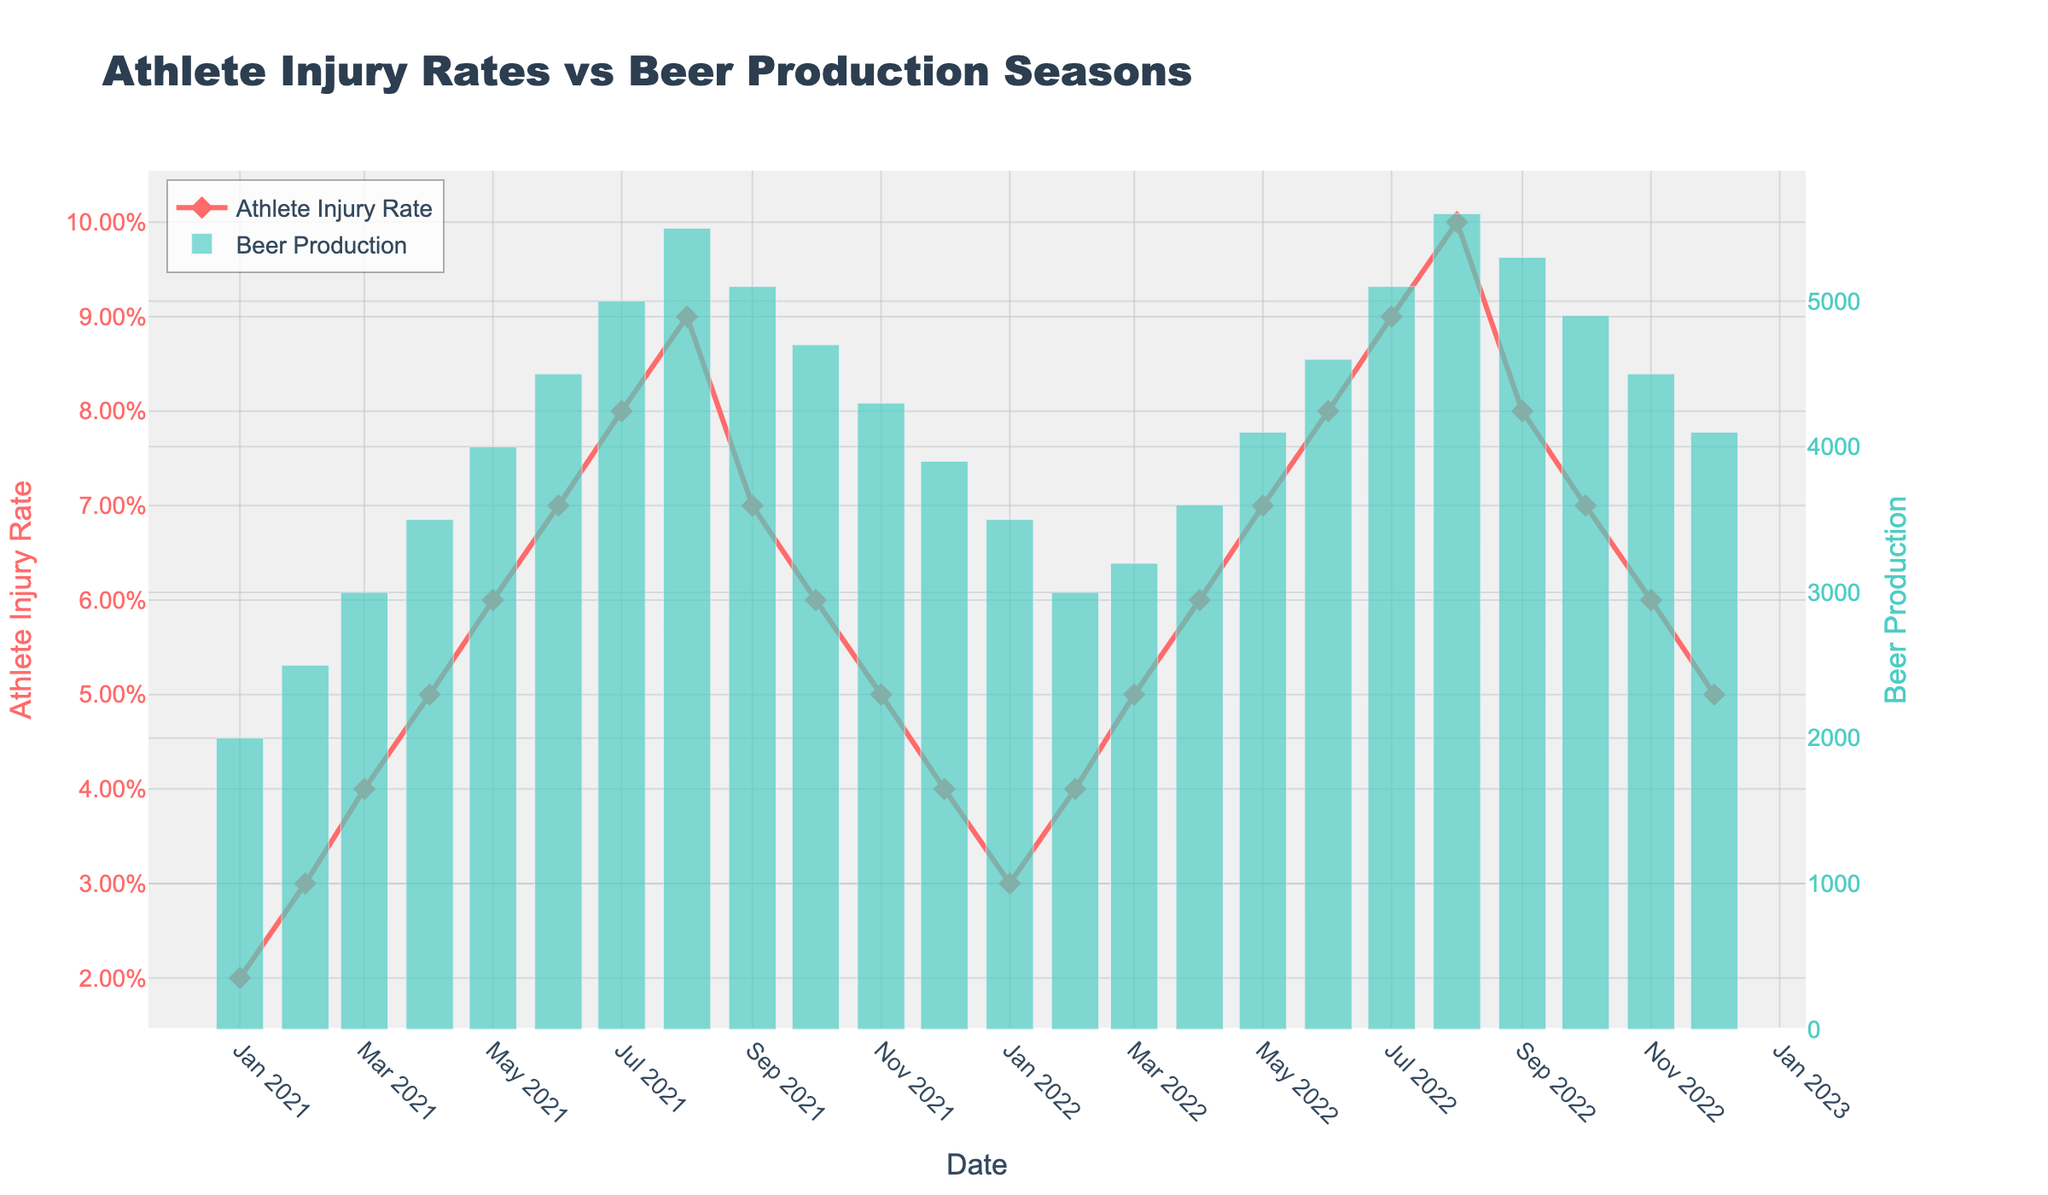What is the title of the plot? The title of a plot is usually located at the top center of the figure. In this case, it reads "Athlete Injury Rates vs Beer Production Seasons".
Answer: Athlete Injury Rates vs Beer Production Seasons Which line color represents the Athlete Injury Rate? The figure shows two different data types with distinct visual appearance: a line with markers and a bar graph. The line represents Athlete Injury Rate, and its color is described in the code as '#FF6B6B', which appears as a reddish color.
Answer: Red What is the color used to represent Beer Production in the bar chart? In the bar chart, the Beer Production data is shown using a specific color. According to the plot settings, the bars are colored '#4ECDC4', which is a shade of green.
Answer: Green When did the Athlete Injury Rate start to decline after peaking in 2022? Look for the highest point on the Athlete Injury Rate line in 2022, which happens around August. Then, trace the line downwards to find the initial decline, which happens in September 2022.
Answer: September 2022 What was the Athlete Injury Rate and Beer Production in July 2021? Find July 2021 on the x-axis and refer to both the line and bar values. The injury rate is 0.08, and beer production is 5000 units.
Answer: Injury Rate: 0.08, Beer Production: 5000 How does the trend of Athlete Injury Rates compare with Beer Production from January to December 2021? Follow the trends of both datasets over the months. The Athlete Injury Rate and Beer Production both increase from January and peak towards August, then decrease towards the end of the year. Their trends show a similar pattern in 2021.
Answer: Both increase then decrease What month had the highest Beer Production and what was the corresponding Athlete Injury Rate? Locate the highest bar for Beer Production, which is in August 2022. The corresponding Athlete Injury Rate is shown on the line graph directly above this bar, which is 0.10.
Answer: August 2022; Injury Rate: 0.10 Calculate the average Athlete Injury Rate for the year 2021. Add all the monthly rates for 2021 (0.02+0.03+0.04+0.05+0.06+0.07+0.08+0.09+0.07+0.06+0.05+0.04), then divide by the number of months (12). The sum is 0.66, so the average is 0.66/12.
Answer: 0.055 How much did Beer Production increase from January to July 2021? Note the Beer Production values for January 2021 (2000) and July 2021 (5000) and calculate the difference: 5000 - 2000.
Answer: 3000 Was there ever a time when the Athlete Injury Rate and Beer Production both declined simultaneously? Observe both the line and bar graph trends together. One instance is between August 2021 and September 2021, where both Injury Rate and Beer Production decrease.
Answer: Yes, between August and September 2021 